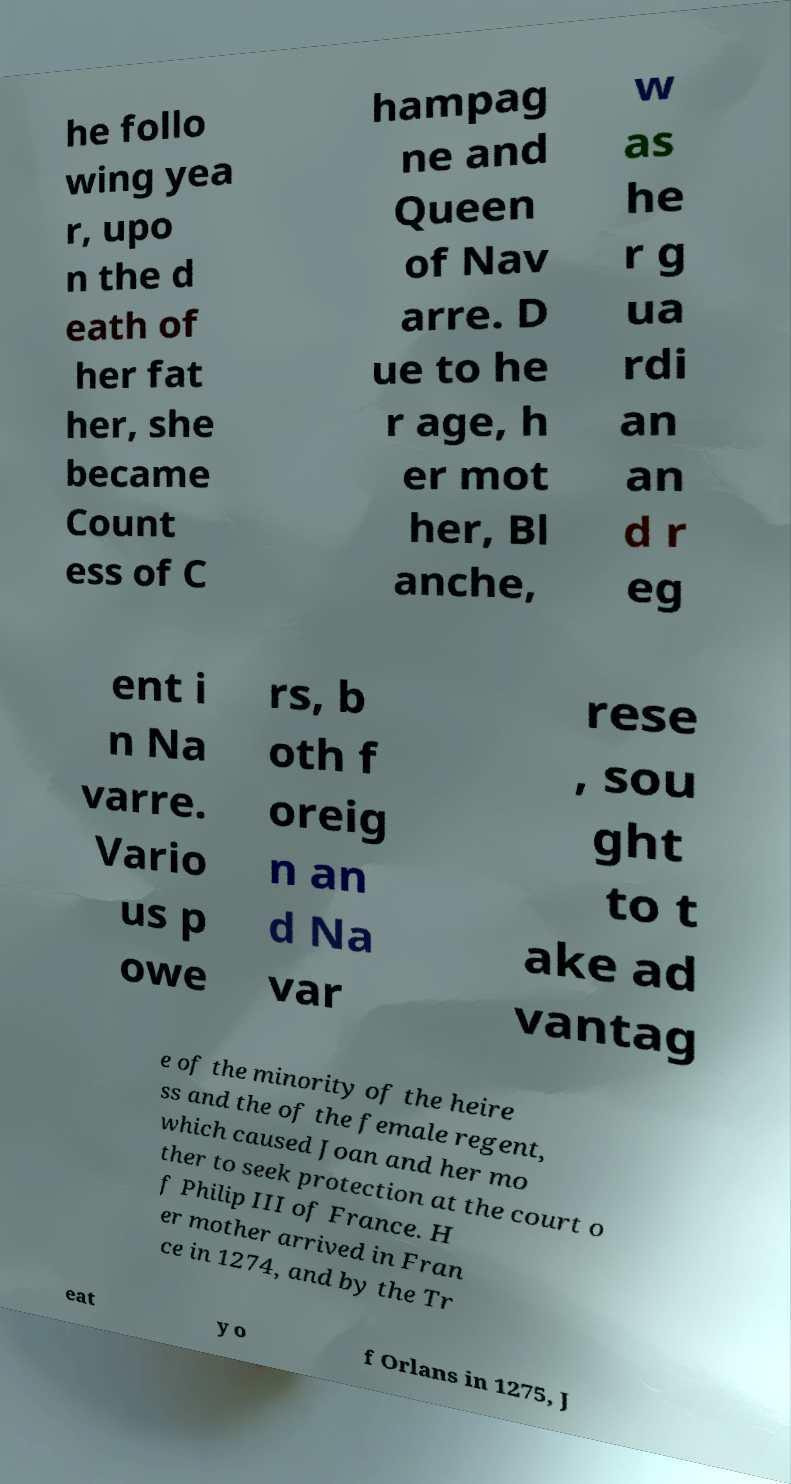There's text embedded in this image that I need extracted. Can you transcribe it verbatim? he follo wing yea r, upo n the d eath of her fat her, she became Count ess of C hampag ne and Queen of Nav arre. D ue to he r age, h er mot her, Bl anche, w as he r g ua rdi an an d r eg ent i n Na varre. Vario us p owe rs, b oth f oreig n an d Na var rese , sou ght to t ake ad vantag e of the minority of the heire ss and the of the female regent, which caused Joan and her mo ther to seek protection at the court o f Philip III of France. H er mother arrived in Fran ce in 1274, and by the Tr eat y o f Orlans in 1275, J 